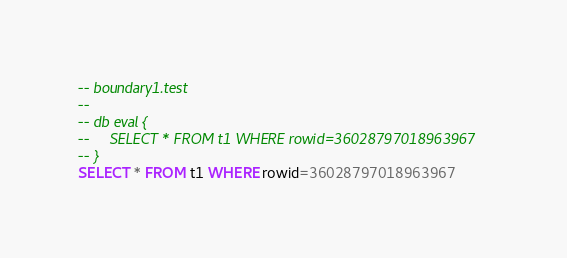<code> <loc_0><loc_0><loc_500><loc_500><_SQL_>-- boundary1.test
-- 
-- db eval {
--     SELECT * FROM t1 WHERE rowid=36028797018963967
-- }
SELECT * FROM t1 WHERE rowid=36028797018963967</code> 